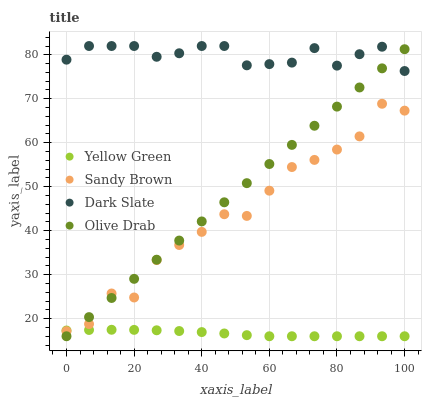Does Yellow Green have the minimum area under the curve?
Answer yes or no. Yes. Does Dark Slate have the maximum area under the curve?
Answer yes or no. Yes. Does Sandy Brown have the minimum area under the curve?
Answer yes or no. No. Does Sandy Brown have the maximum area under the curve?
Answer yes or no. No. Is Olive Drab the smoothest?
Answer yes or no. Yes. Is Sandy Brown the roughest?
Answer yes or no. Yes. Is Yellow Green the smoothest?
Answer yes or no. No. Is Yellow Green the roughest?
Answer yes or no. No. Does Yellow Green have the lowest value?
Answer yes or no. Yes. Does Sandy Brown have the lowest value?
Answer yes or no. No. Does Dark Slate have the highest value?
Answer yes or no. Yes. Does Sandy Brown have the highest value?
Answer yes or no. No. Is Sandy Brown less than Dark Slate?
Answer yes or no. Yes. Is Dark Slate greater than Sandy Brown?
Answer yes or no. Yes. Does Yellow Green intersect Sandy Brown?
Answer yes or no. Yes. Is Yellow Green less than Sandy Brown?
Answer yes or no. No. Is Yellow Green greater than Sandy Brown?
Answer yes or no. No. Does Sandy Brown intersect Dark Slate?
Answer yes or no. No. 